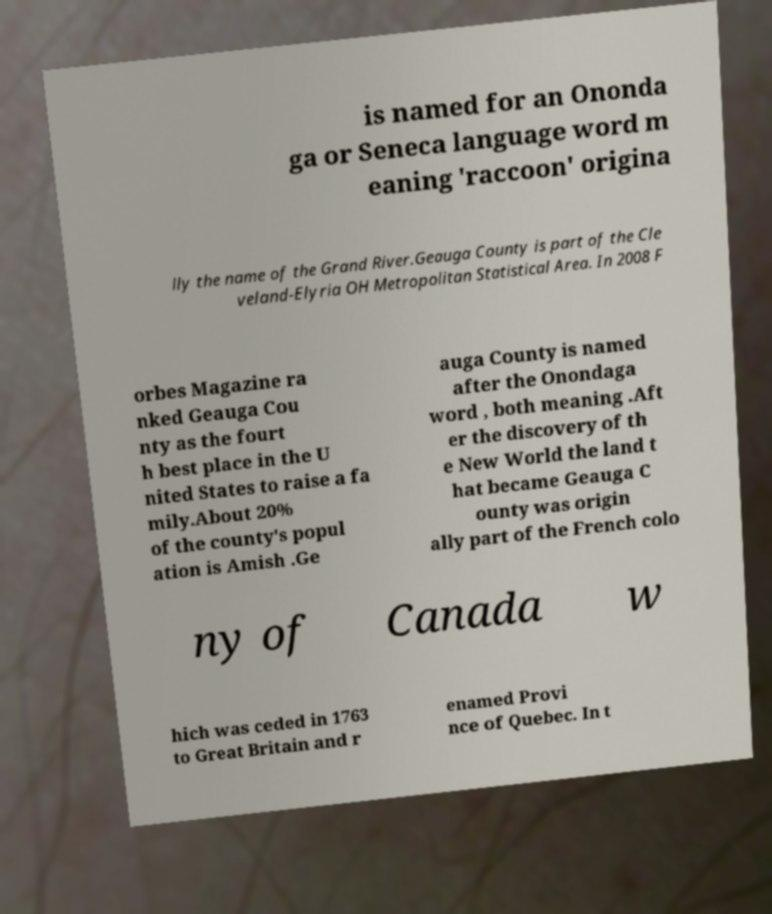For documentation purposes, I need the text within this image transcribed. Could you provide that? is named for an Ononda ga or Seneca language word m eaning 'raccoon' origina lly the name of the Grand River.Geauga County is part of the Cle veland-Elyria OH Metropolitan Statistical Area. In 2008 F orbes Magazine ra nked Geauga Cou nty as the fourt h best place in the U nited States to raise a fa mily.About 20% of the county's popul ation is Amish .Ge auga County is named after the Onondaga word , both meaning .Aft er the discovery of th e New World the land t hat became Geauga C ounty was origin ally part of the French colo ny of Canada w hich was ceded in 1763 to Great Britain and r enamed Provi nce of Quebec. In t 